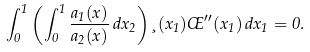<formula> <loc_0><loc_0><loc_500><loc_500>\int _ { 0 } ^ { 1 } \left ( \int _ { 0 } ^ { 1 } \frac { a _ { 1 } ( x ) } { a _ { 2 } ( x ) } \, d x _ { 2 } \right ) \xi ( x _ { 1 } ) \phi ^ { \prime \prime } ( x _ { 1 } ) \, d x _ { 1 } = 0 .</formula> 